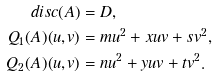Convert formula to latex. <formula><loc_0><loc_0><loc_500><loc_500>d i s c ( A ) & = D , \\ Q _ { 1 } ( A ) ( u , v ) & = m u ^ { 2 } + x u v + s v ^ { 2 } , \\ Q _ { 2 } ( A ) ( u , v ) & = n u ^ { 2 } + y u v + t v ^ { 2 } .</formula> 